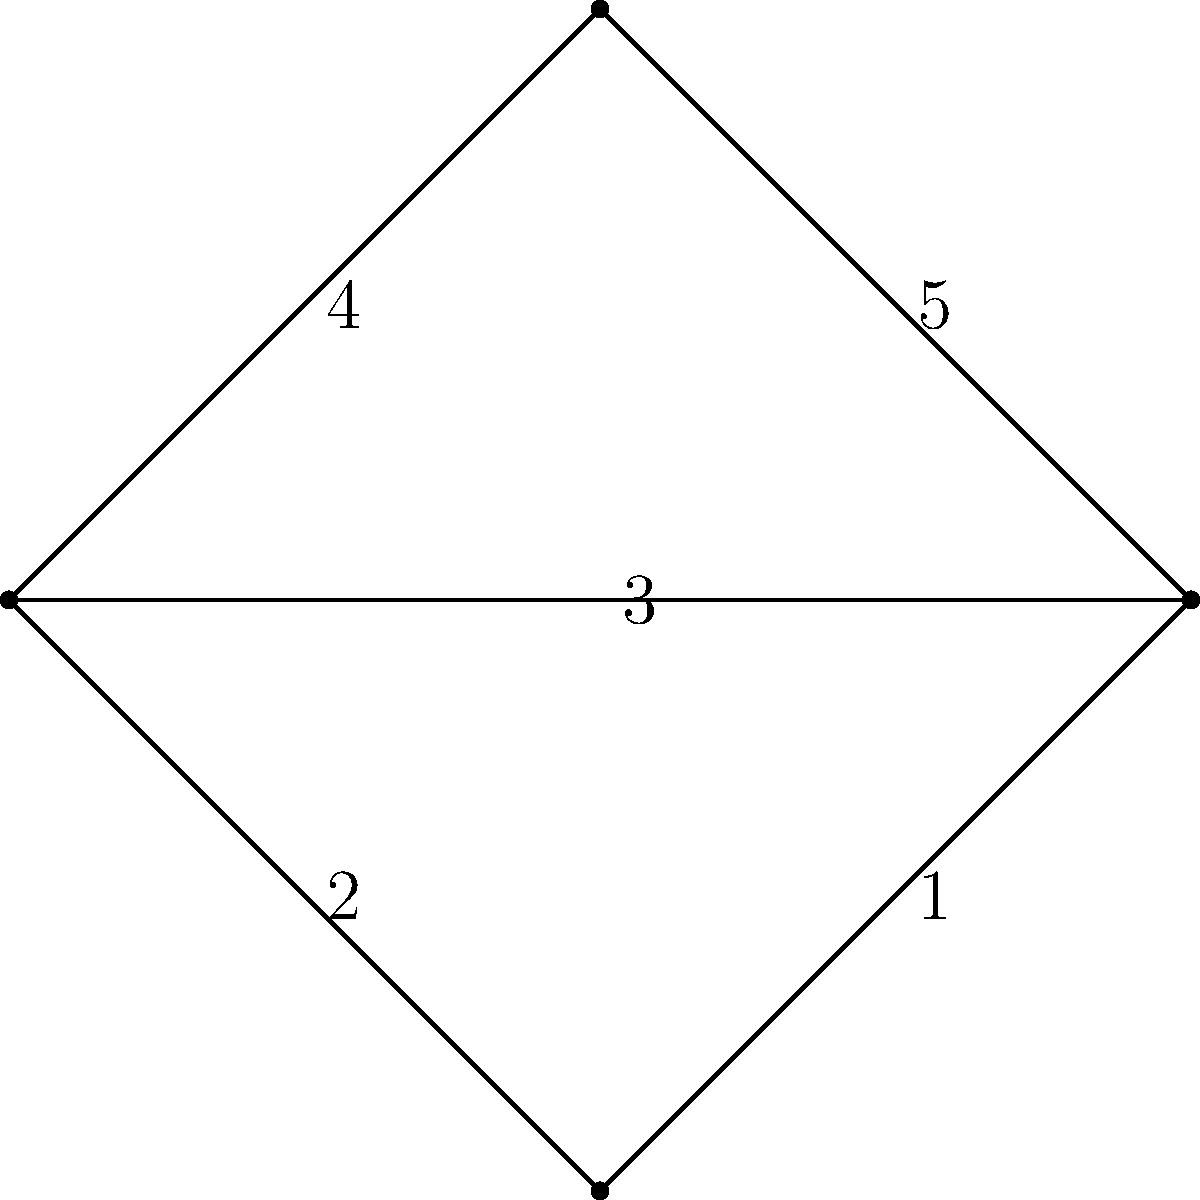In the graph above, what is the total weight of the minimum spanning tree? To find the minimum spanning tree (MST) of this graph, we can use Kruskal's algorithm:

1. Sort all edges by weight in ascending order:
   (2,3) with weight 1
   (0,3) with weight 2
   (0,2) with weight 3
   (0,1) with weight 4
   (1,2) with weight 5

2. Start with an empty MST and add edges in order, skipping those that would create a cycle:
   - Add (2,3) with weight 1
   - Add (0,3) with weight 2
   - Add (0,2) with weight 3

3. At this point, we have connected all vertices, so we stop.

4. The MST consists of edges (2,3), (0,3), and (0,2).

5. Calculate the total weight: 1 + 2 + 3 = 6

Therefore, the total weight of the minimum spanning tree is 6.
Answer: 6 